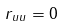Convert formula to latex. <formula><loc_0><loc_0><loc_500><loc_500>r _ { u u } = 0</formula> 